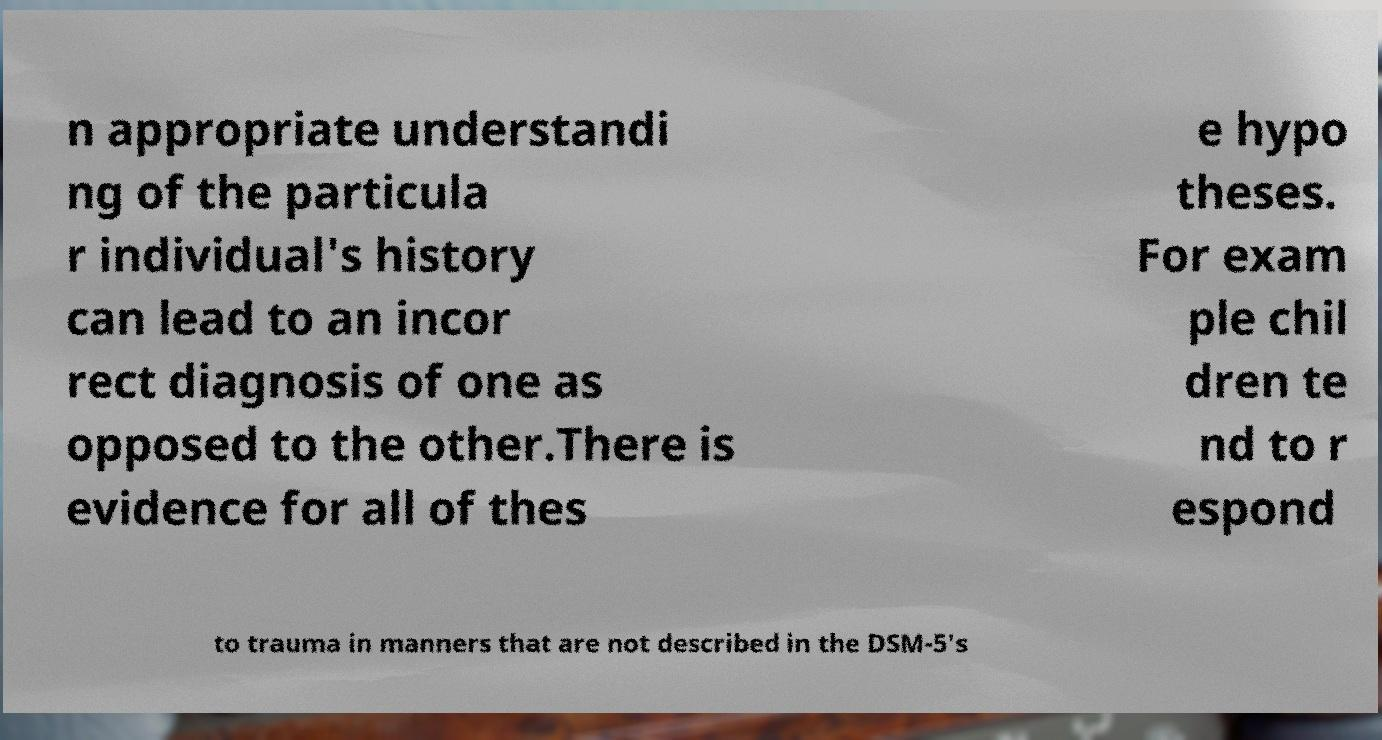Please identify and transcribe the text found in this image. n appropriate understandi ng of the particula r individual's history can lead to an incor rect diagnosis of one as opposed to the other.There is evidence for all of thes e hypo theses. For exam ple chil dren te nd to r espond to trauma in manners that are not described in the DSM-5's 